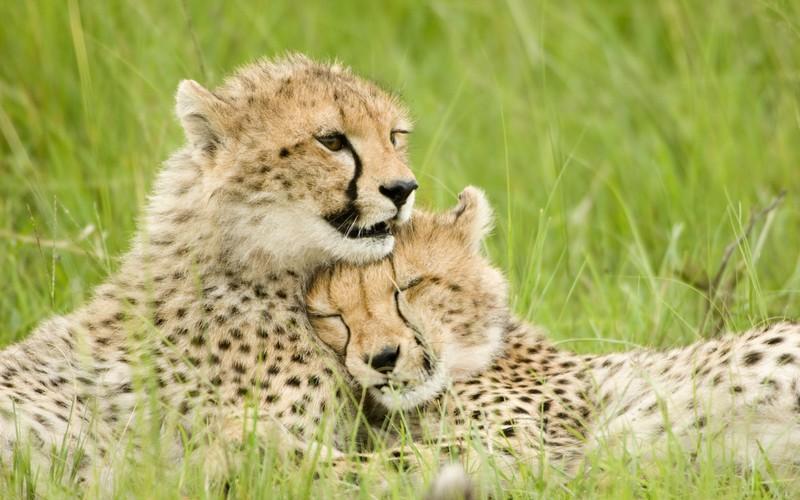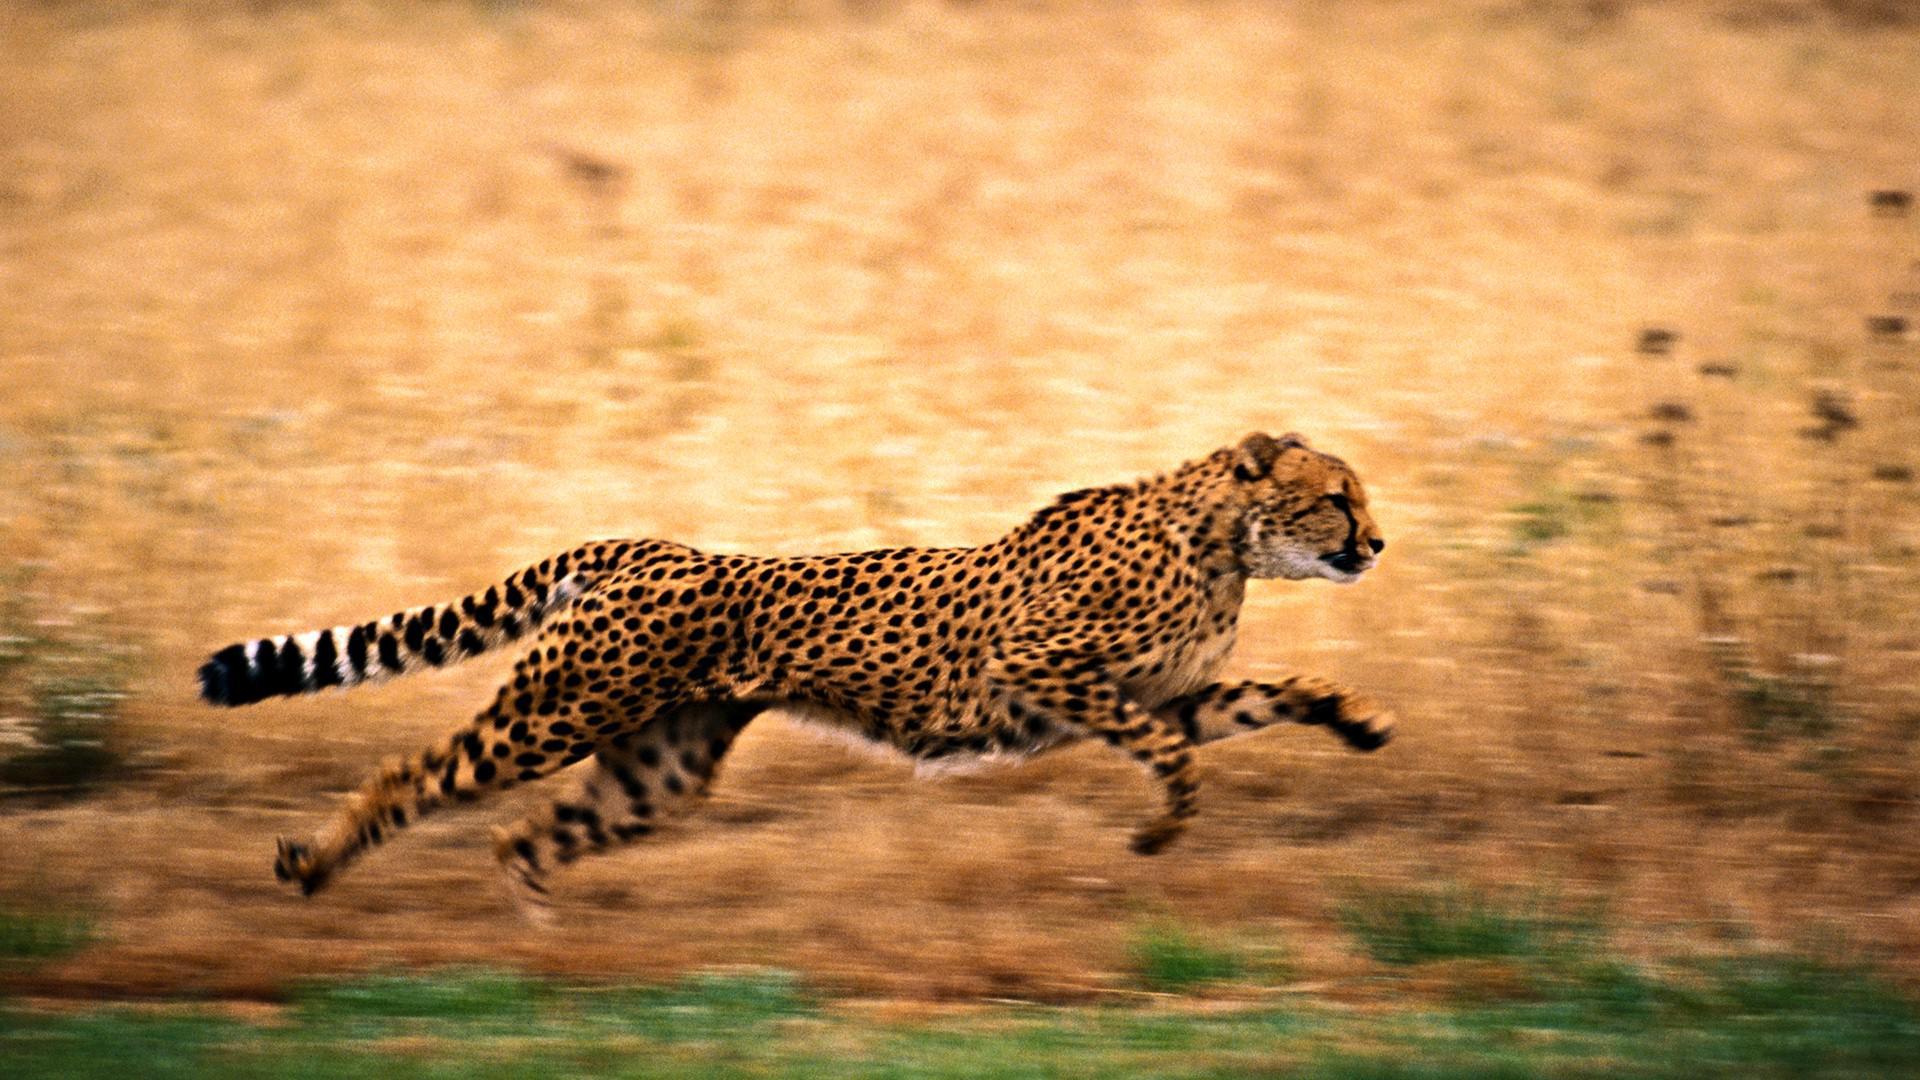The first image is the image on the left, the second image is the image on the right. Examine the images to the left and right. Is the description "An image shows a cheetah bounding across the grass with front paws off the ground." accurate? Answer yes or no. Yes. The first image is the image on the left, the second image is the image on the right. Examine the images to the left and right. Is the description "The left image contains at least two cheetahs." accurate? Answer yes or no. Yes. 